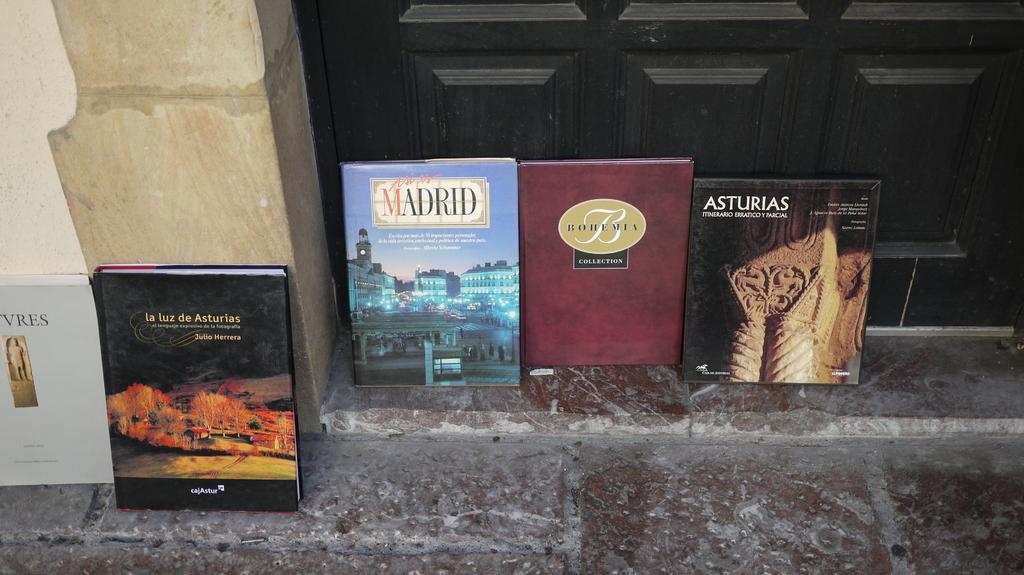<image>
Describe the image concisely. Five books about Spain are displayed by a door. 